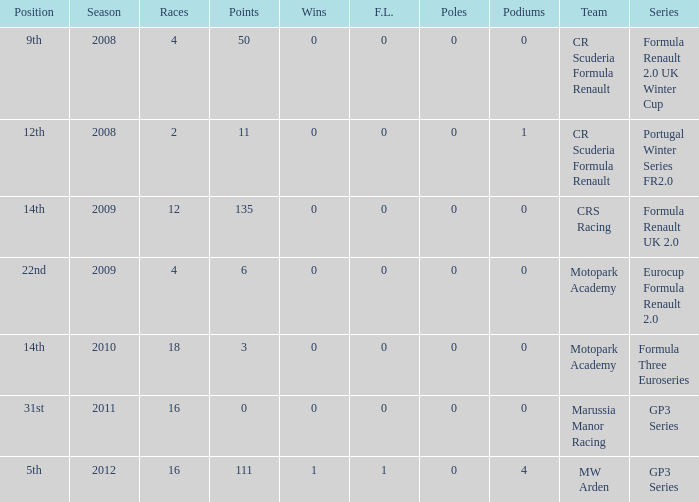Could you parse the entire table? {'header': ['Position', 'Season', 'Races', 'Points', 'Wins', 'F.L.', 'Poles', 'Podiums', 'Team', 'Series'], 'rows': [['9th', '2008', '4', '50', '0', '0', '0', '0', 'CR Scuderia Formula Renault', 'Formula Renault 2.0 UK Winter Cup'], ['12th', '2008', '2', '11', '0', '0', '0', '1', 'CR Scuderia Formula Renault', 'Portugal Winter Series FR2.0'], ['14th', '2009', '12', '135', '0', '0', '0', '0', 'CRS Racing', 'Formula Renault UK 2.0'], ['22nd', '2009', '4', '6', '0', '0', '0', '0', 'Motopark Academy', 'Eurocup Formula Renault 2.0'], ['14th', '2010', '18', '3', '0', '0', '0', '0', 'Motopark Academy', 'Formula Three Euroseries'], ['31st', '2011', '16', '0', '0', '0', '0', '0', 'Marussia Manor Racing', 'GP3 Series'], ['5th', '2012', '16', '111', '1', '1', '0', '4', 'MW Arden', 'GP3 Series']]} What are the most poles listed? 0.0. 